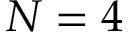Convert formula to latex. <formula><loc_0><loc_0><loc_500><loc_500>N = 4</formula> 